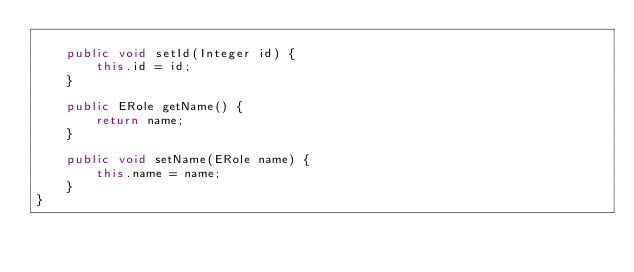Convert code to text. <code><loc_0><loc_0><loc_500><loc_500><_Java_>
    public void setId(Integer id) {
        this.id = id;
    }

    public ERole getName() {
        return name;
    }

    public void setName(ERole name) {
        this.name = name;
    }
}
</code> 